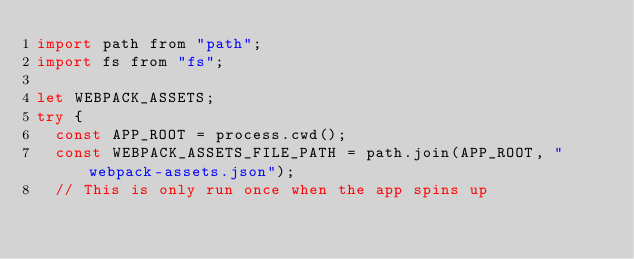Convert code to text. <code><loc_0><loc_0><loc_500><loc_500><_JavaScript_>import path from "path";
import fs from "fs";

let WEBPACK_ASSETS;
try {
  const APP_ROOT = process.cwd();
  const WEBPACK_ASSETS_FILE_PATH = path.join(APP_ROOT, "webpack-assets.json");
  // This is only run once when the app spins up</code> 